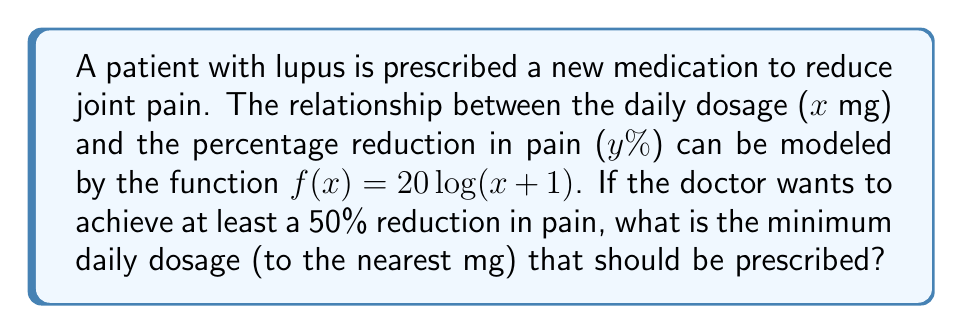Teach me how to tackle this problem. To solve this problem, we need to follow these steps:

1) We want to find x when y ≥ 50. So, we set up the equation:
   $50 \leq 20\log(x+1)$

2) Divide both sides by 20:
   $\frac{50}{20} \leq \log(x+1)$
   $2.5 \leq \log(x+1)$

3) Apply the exponential function (base e) to both sides:
   $e^{2.5} \leq e^{\log(x+1)}$
   $e^{2.5} \leq x+1$

4) Simplify the left side:
   $12.1825... \leq x+1$

5) Subtract 1 from both sides:
   $11.1825... \leq x$

6) Round up to the nearest whole number (since we can't prescribe partial milligrams and we need at least this dosage):
   $x \geq 12$

Therefore, the minimum daily dosage should be 12 mg.
Answer: 12 mg 